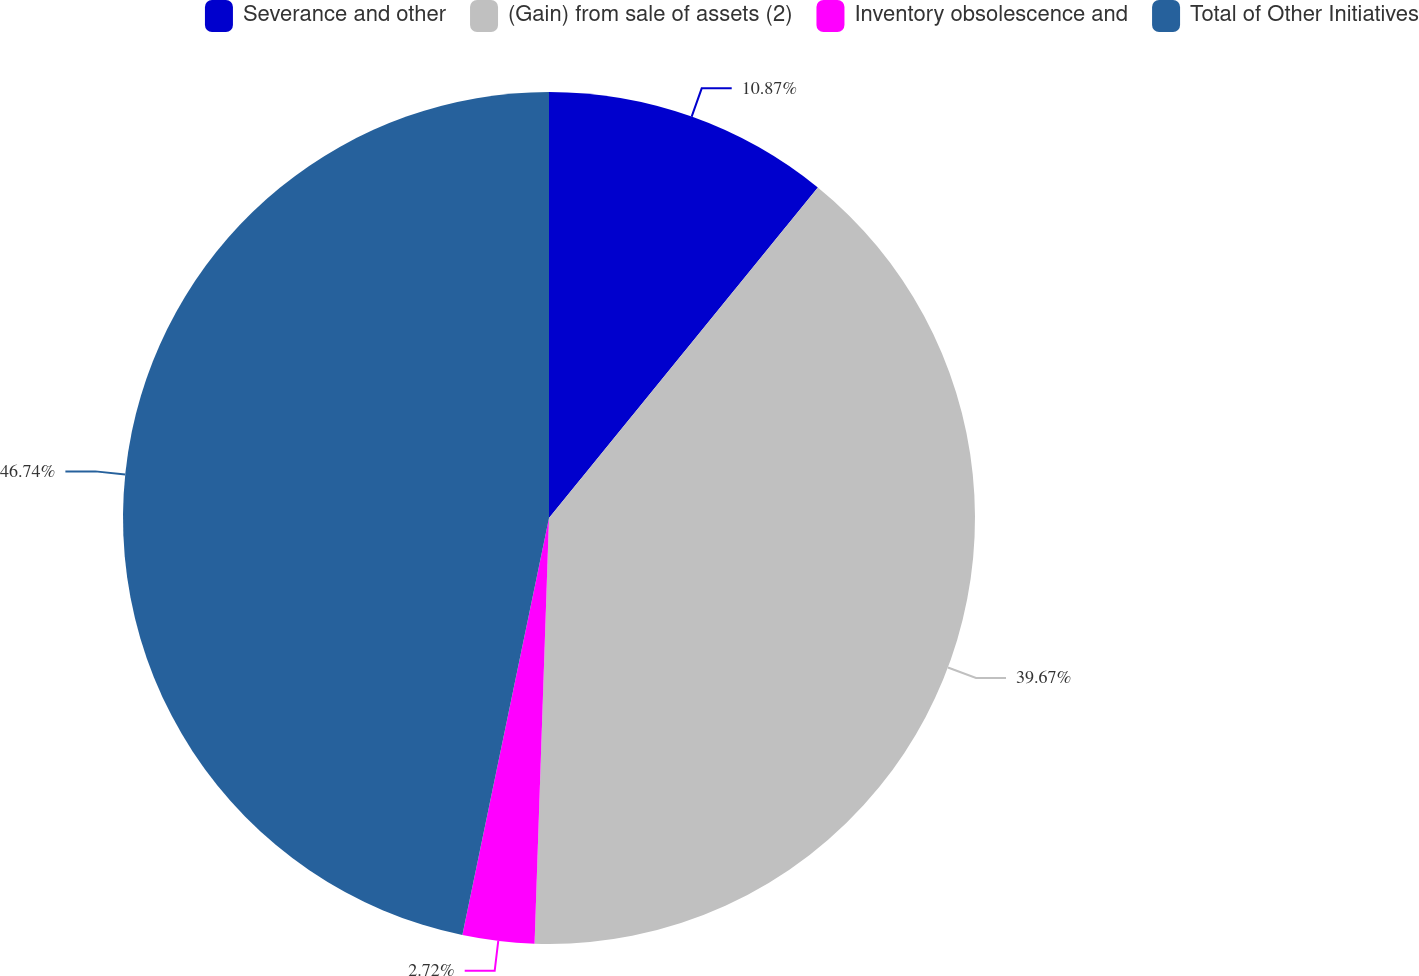<chart> <loc_0><loc_0><loc_500><loc_500><pie_chart><fcel>Severance and other<fcel>(Gain) from sale of assets (2)<fcel>Inventory obsolescence and<fcel>Total of Other Initiatives<nl><fcel>10.87%<fcel>39.67%<fcel>2.72%<fcel>46.74%<nl></chart> 